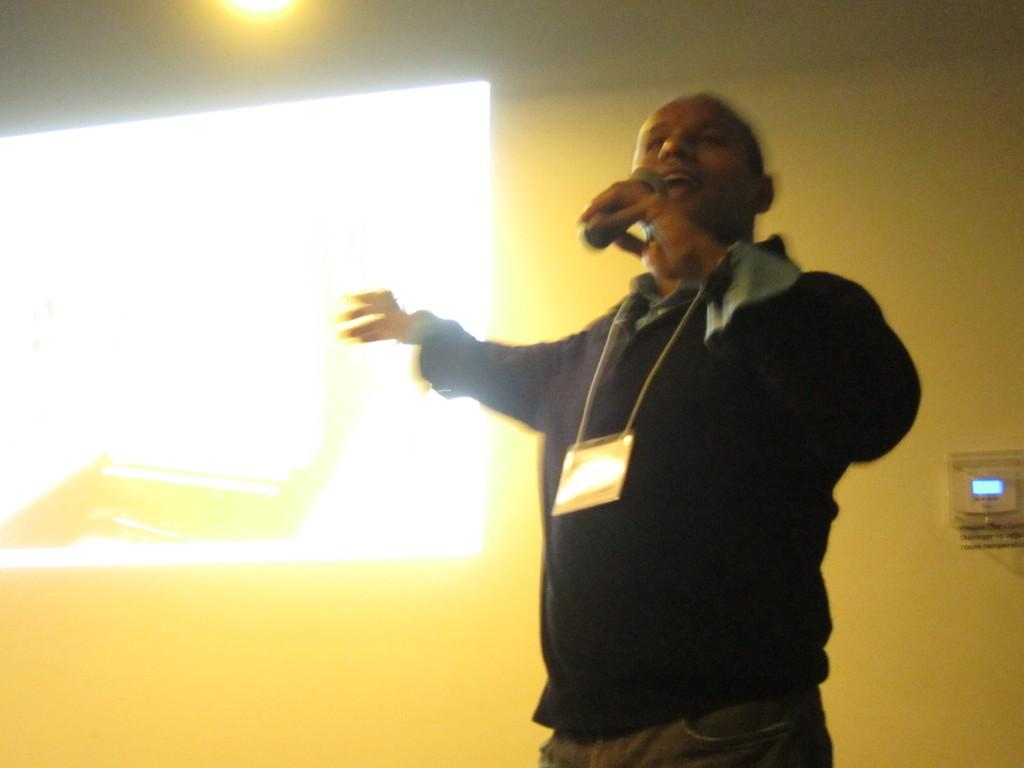What is the man in the image doing? The man is standing in the image and holding a microphone in his hand. What can be seen in the background of the image? There is a wall and a screen in the background of the image. What is the man's temper like in the image? There is no information about the man's temper in the image. 